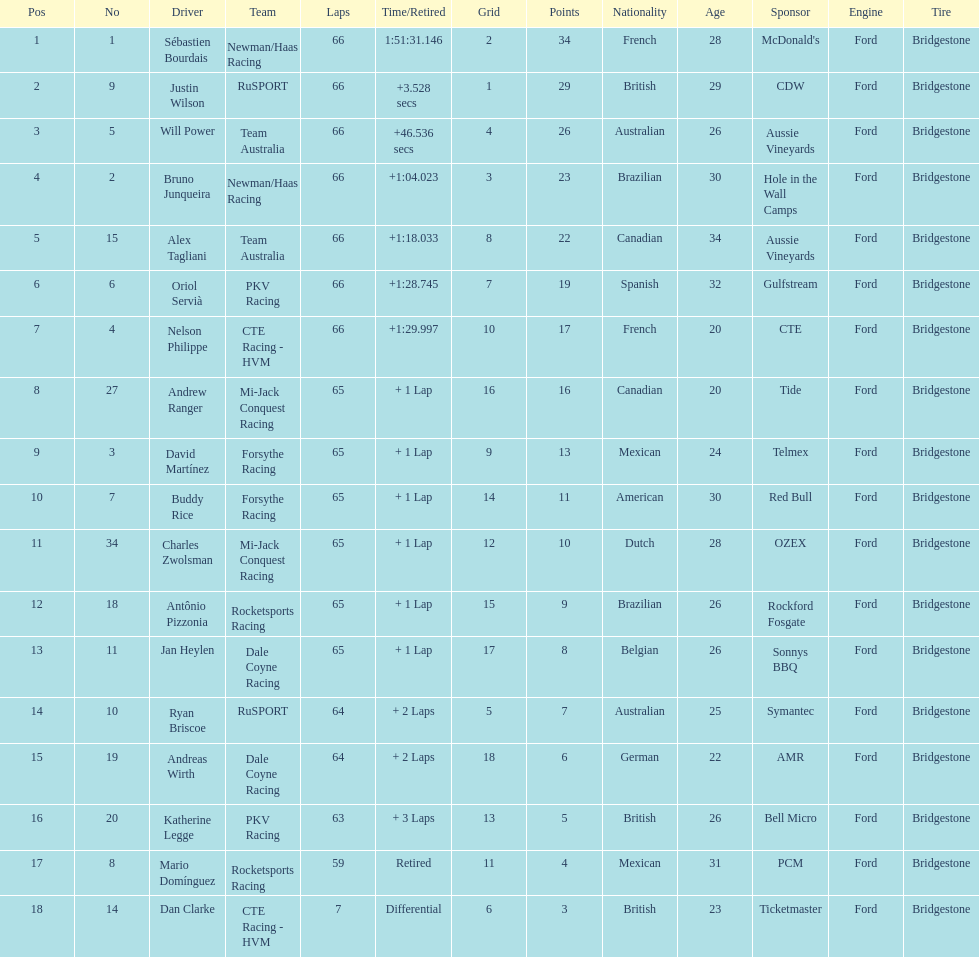How many drivers did not make more than 60 laps? 2. 